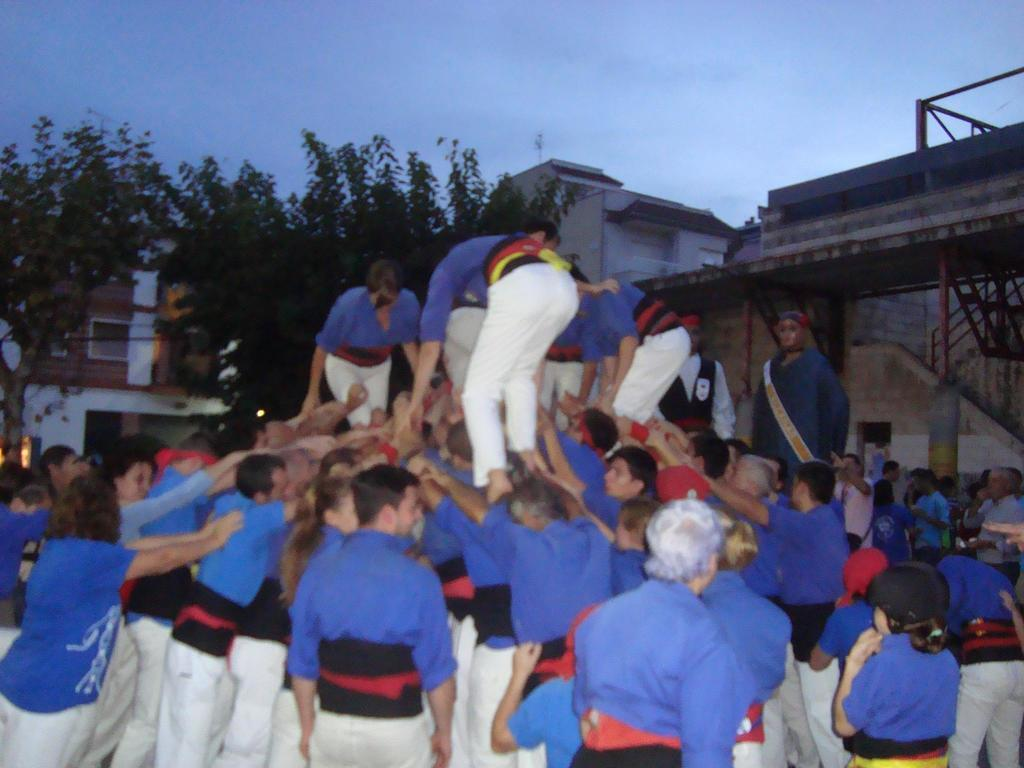What are the persons in the image doing? The persons in the image are climbing other persons. What type of natural elements can be seen in the image? There are trees in the image. What type of man-made structures are present in the image? There are buildings and a staircase in the image. What type of artistic objects can be seen in the image? There are statues in the image. What is visible in the sky in the image? The sky is visible in the image. What type of jewel can be seen on the head of the person climbing in the image? There is no jewel visible on the head of any person in the image. 